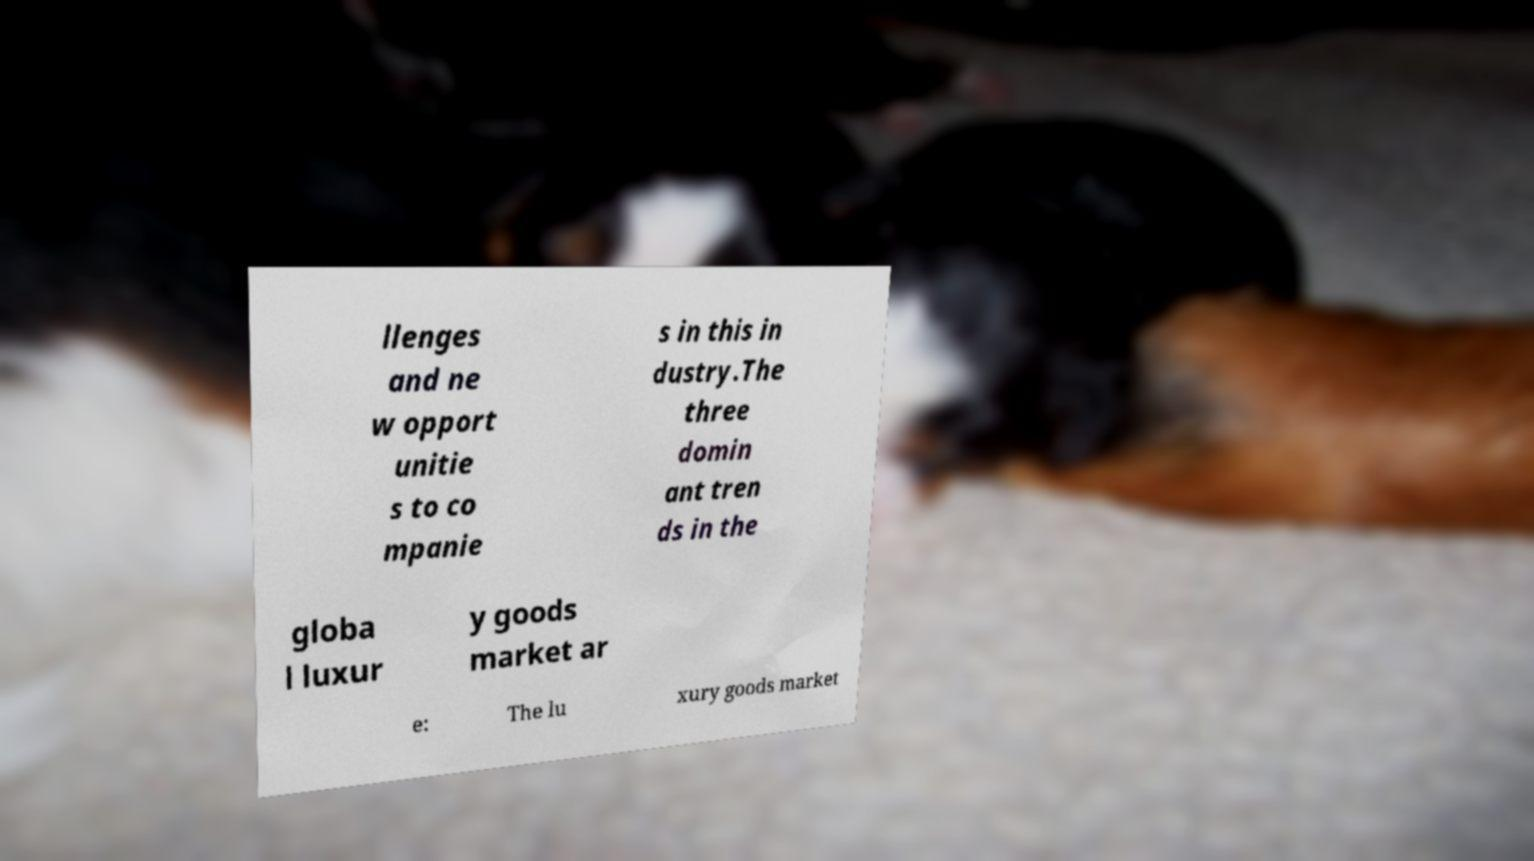Please identify and transcribe the text found in this image. llenges and ne w opport unitie s to co mpanie s in this in dustry.The three domin ant tren ds in the globa l luxur y goods market ar e: The lu xury goods market 